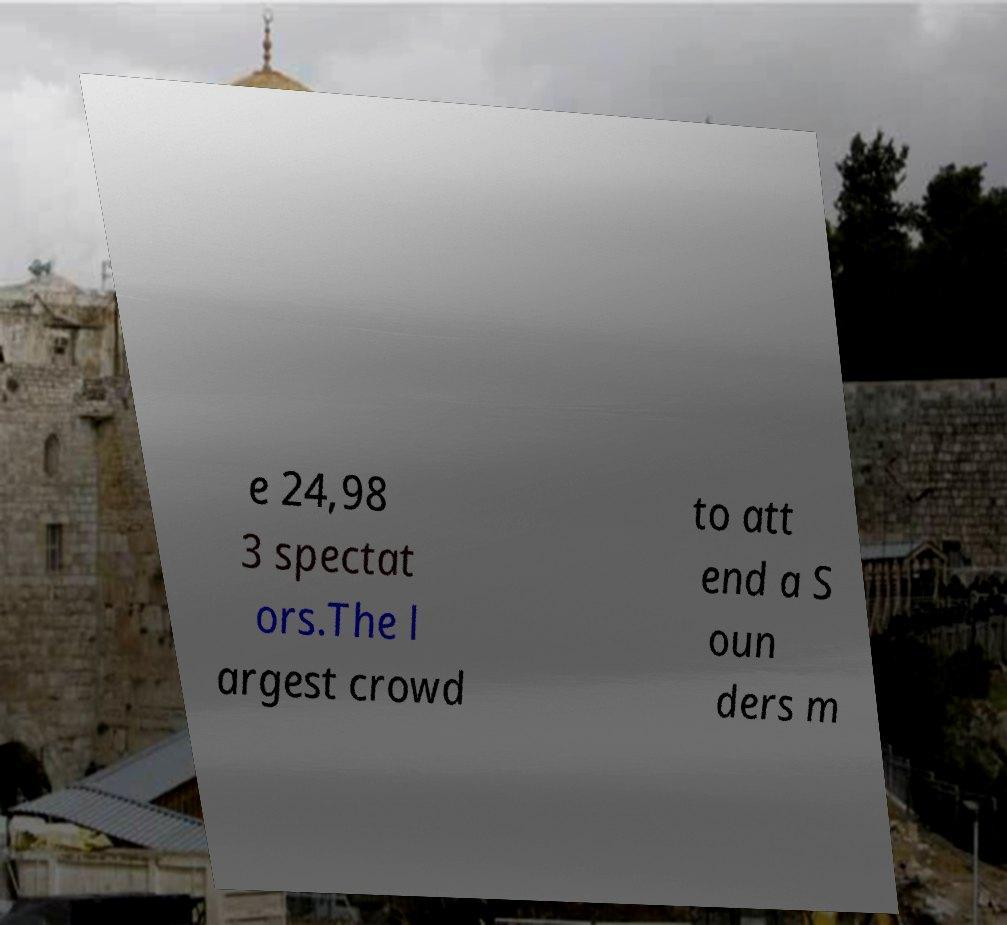Could you extract and type out the text from this image? e 24,98 3 spectat ors.The l argest crowd to att end a S oun ders m 